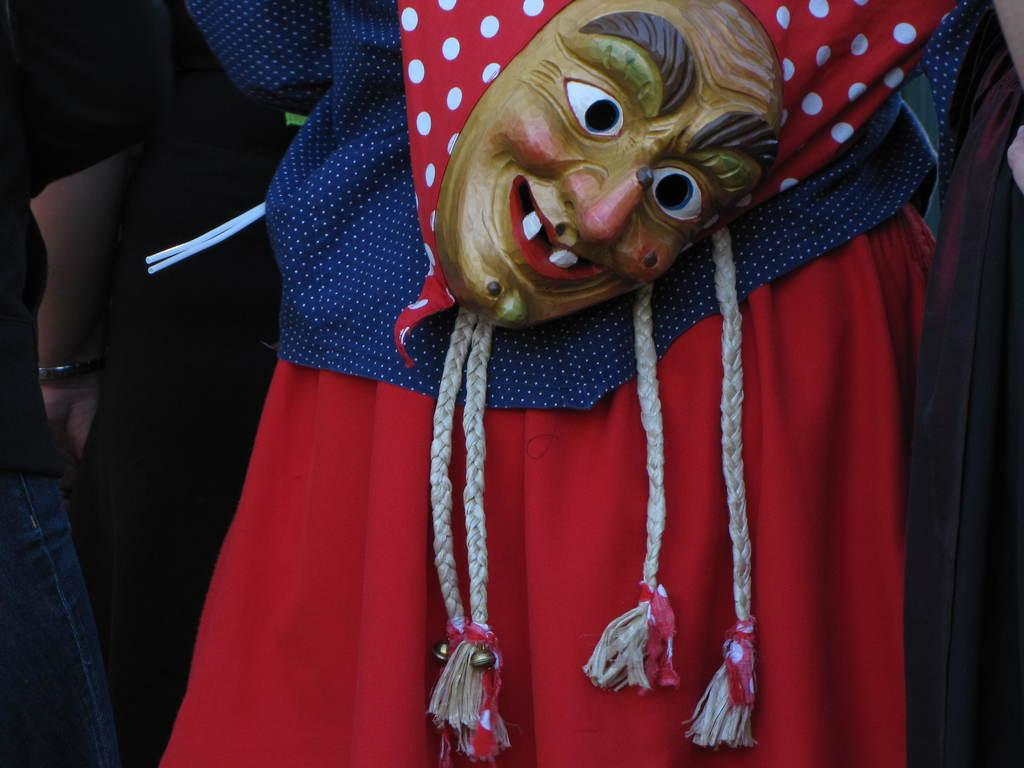How many people are present in the image? There are people standing in the image. Can you describe the attire of one of the people? One person is wearing a costume. What additional accessory is the person in the costume wearing? The person in the costume is also wearing a mask. Can you tell me how many worms are crawling on the ground in the image? There is no mention of worms or any crawling creatures in the image. What type of land is visible in the background of the image? There is no reference to any specific type of land or background in the image. 